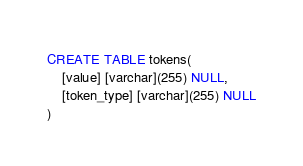<code> <loc_0><loc_0><loc_500><loc_500><_SQL_>CREATE TABLE tokens(
	[value] [varchar](255) NULL,
	[token_type] [varchar](255) NULL
)</code> 